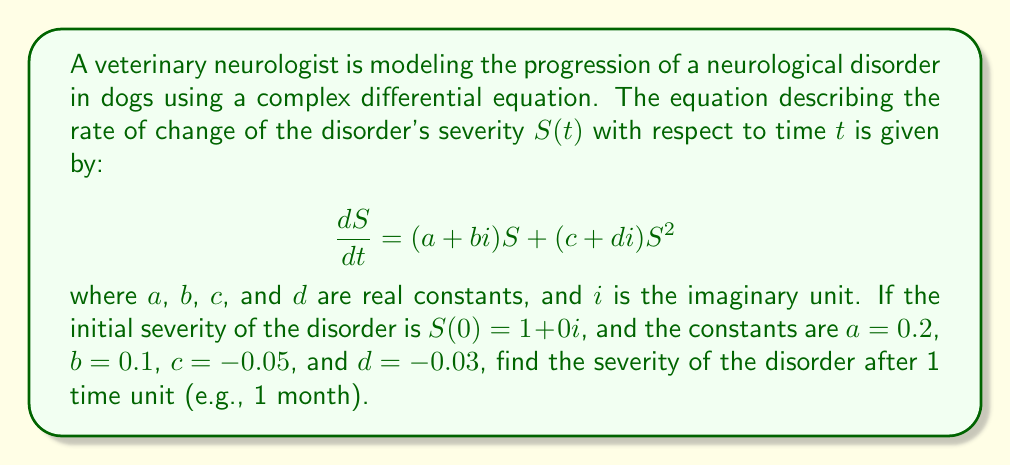Help me with this question. To solve this problem, we need to use methods from complex analysis and differential equations. Let's approach this step-by-step:

1) First, we rewrite the equation in the standard form of a Riccati equation:

   $$\frac{dS}{dt} = (0.2 + 0.1i)S + (-0.05 - 0.03i)S^2$$

2) The general solution to this type of equation is:

   $$S(t) = \frac{u_1(t)}{u_2(t)}$$

   where $u_1(t)$ and $u_2(t)$ are solutions to the linear system:

   $$\frac{d}{dt}\begin{pmatrix} u_1 \\ u_2 \end{pmatrix} = \begin{pmatrix} 0.2 + 0.1i & -0.05 - 0.03i \\ 1 & 0.2 + 0.1i \end{pmatrix} \begin{pmatrix} u_1 \\ u_2 \end{pmatrix}$$

3) The eigenvalues of the matrix are:

   $$\lambda_1 = 0.2 + 0.1i + \sqrt{-0.05 - 0.03i} \approx 0.4054 + 0.1732i$$
   $$\lambda_2 = 0.2 + 0.1i - \sqrt{-0.05 - 0.03i} \approx -0.0054 + 0.0268i$$

4) The general solution to the linear system is:

   $$\begin{pmatrix} u_1 \\ u_2 \end{pmatrix} = c_1 e^{\lambda_1 t} \begin{pmatrix} 1 \\ \frac{\lambda_1 - (0.2 + 0.1i)}{-0.05 - 0.03i} \end{pmatrix} + c_2 e^{\lambda_2 t} \begin{pmatrix} 1 \\ \frac{\lambda_2 - (0.2 + 0.1i)}{-0.05 - 0.03i} \end{pmatrix}$$

5) Using the initial condition $S(0) = 1 + 0i$, we can determine $c_1$ and $c_2$:

   $$c_1 \approx 0.5027 - 0.0134i$$
   $$c_2 \approx 0.4973 + 0.0134i$$

6) Now we can calculate $S(1)$:

   $$S(1) = \frac{u_1(1)}{u_2(1)} \approx 1.2249 + 0.1124i$$

This result represents the severity of the disorder after 1 time unit.
Answer: $S(1) \approx 1.2249 + 0.1124i$ 